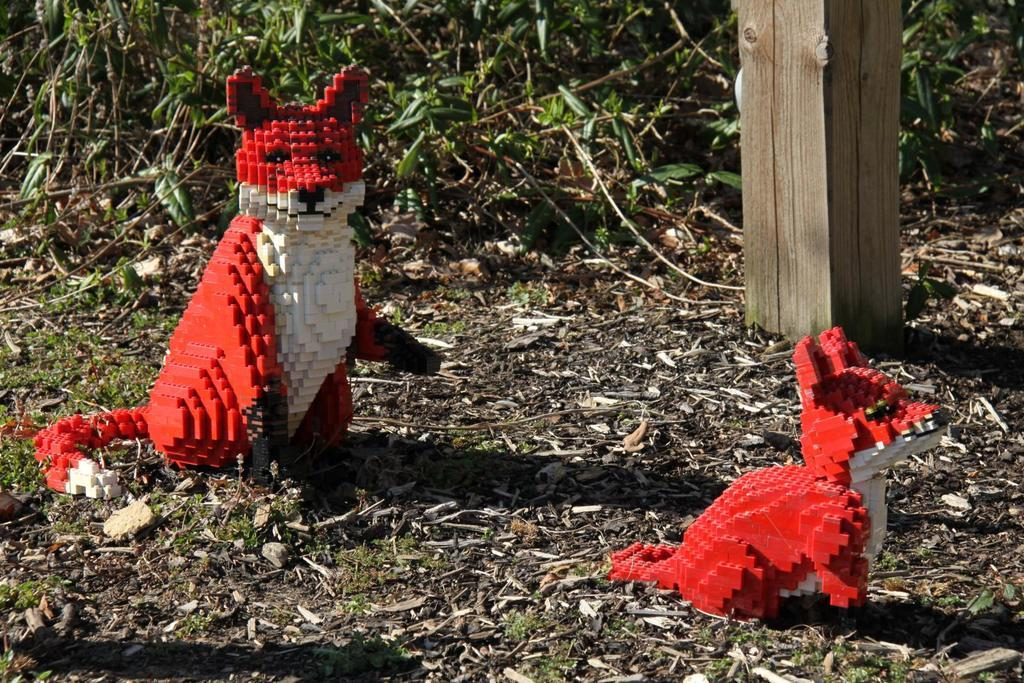What objects are on the ground in the image? There are toys, small wooden pieces, plants, and a wooden pole on the ground. Can you describe the wooden pieces in more detail? The wooden pieces are small and scattered on the ground. What type of plants are present in the image? The plants are visible on the ground, but their specific type is not mentioned in the facts. What is the wooden pole used for? The purpose of the wooden pole is not mentioned in the facts. What type of frame is visible in the image? There is no frame present in the image. Who gave their approval for the advertisement in the image? There is no advertisement present in the image. 